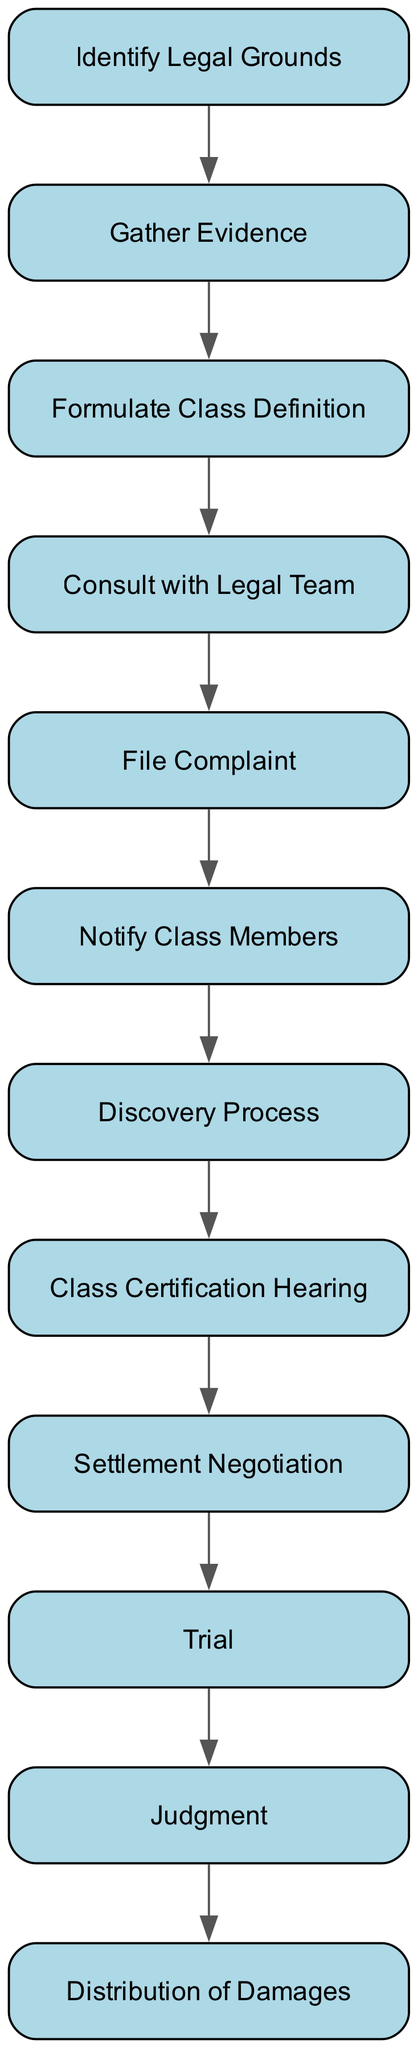What is the first step in the process for filing a class action lawsuit? The first step is "Identify Legal Grounds," which involves assessing the basis for the class action, such as product defects or false advertising.
Answer: Identify Legal Grounds How many major steps are there in the flowchart? By counting each distinct phase in the chart, from "Identify Legal Grounds" to "Distribution of Damages," there are a total of twelve major steps in the process.
Answer: Twelve What is the last step in the process? The last step depicted in the flowchart is "Distribution of Damages," which outlines the action of distributing any awarded damages to the class members.
Answer: Distribution of Damages Which step follows "Class Certification Hearing"? After the "Class Certification Hearing," the next step in the process is "Settlement Negotiation," where potential settlement options are discussed with the automotive manufacturer.
Answer: Settlement Negotiation What action needs to be taken before filing the complaint? Before filing the complaint, one must "Consult with Legal Team" to engage with lawyers specializing in class actions, ensuring the case is evaluated properly.
Answer: Consult with Legal Team What is the purpose of the "Discovery Process"? The "Discovery Process" serves as a pre-trial phase where evidence is exchanged between the parties involved in the lawsuit, facilitating a fair trial.
Answer: Evidence exchange How does "Notify Class Members" relate to the outcome of the lawsuit? "Notify Class Members" is crucial as it informs potential class members about the lawsuit, which impacts their ability to participate and receive any potential damages awarded.
Answer: Inform potential class members What step occurs if no settlement is reached? If no settlement is reached, the case proceeds to the "Trial," where the evidence and arguments will be presented before a judge or jury.
Answer: Trial What type of assessment is performed during "Gather Evidence"? During "Gather Evidence," an assessment is made through collecting documentation, witness statements, and expert opinions pertaining to the automotive issue being litigated.
Answer: Collect documentation 